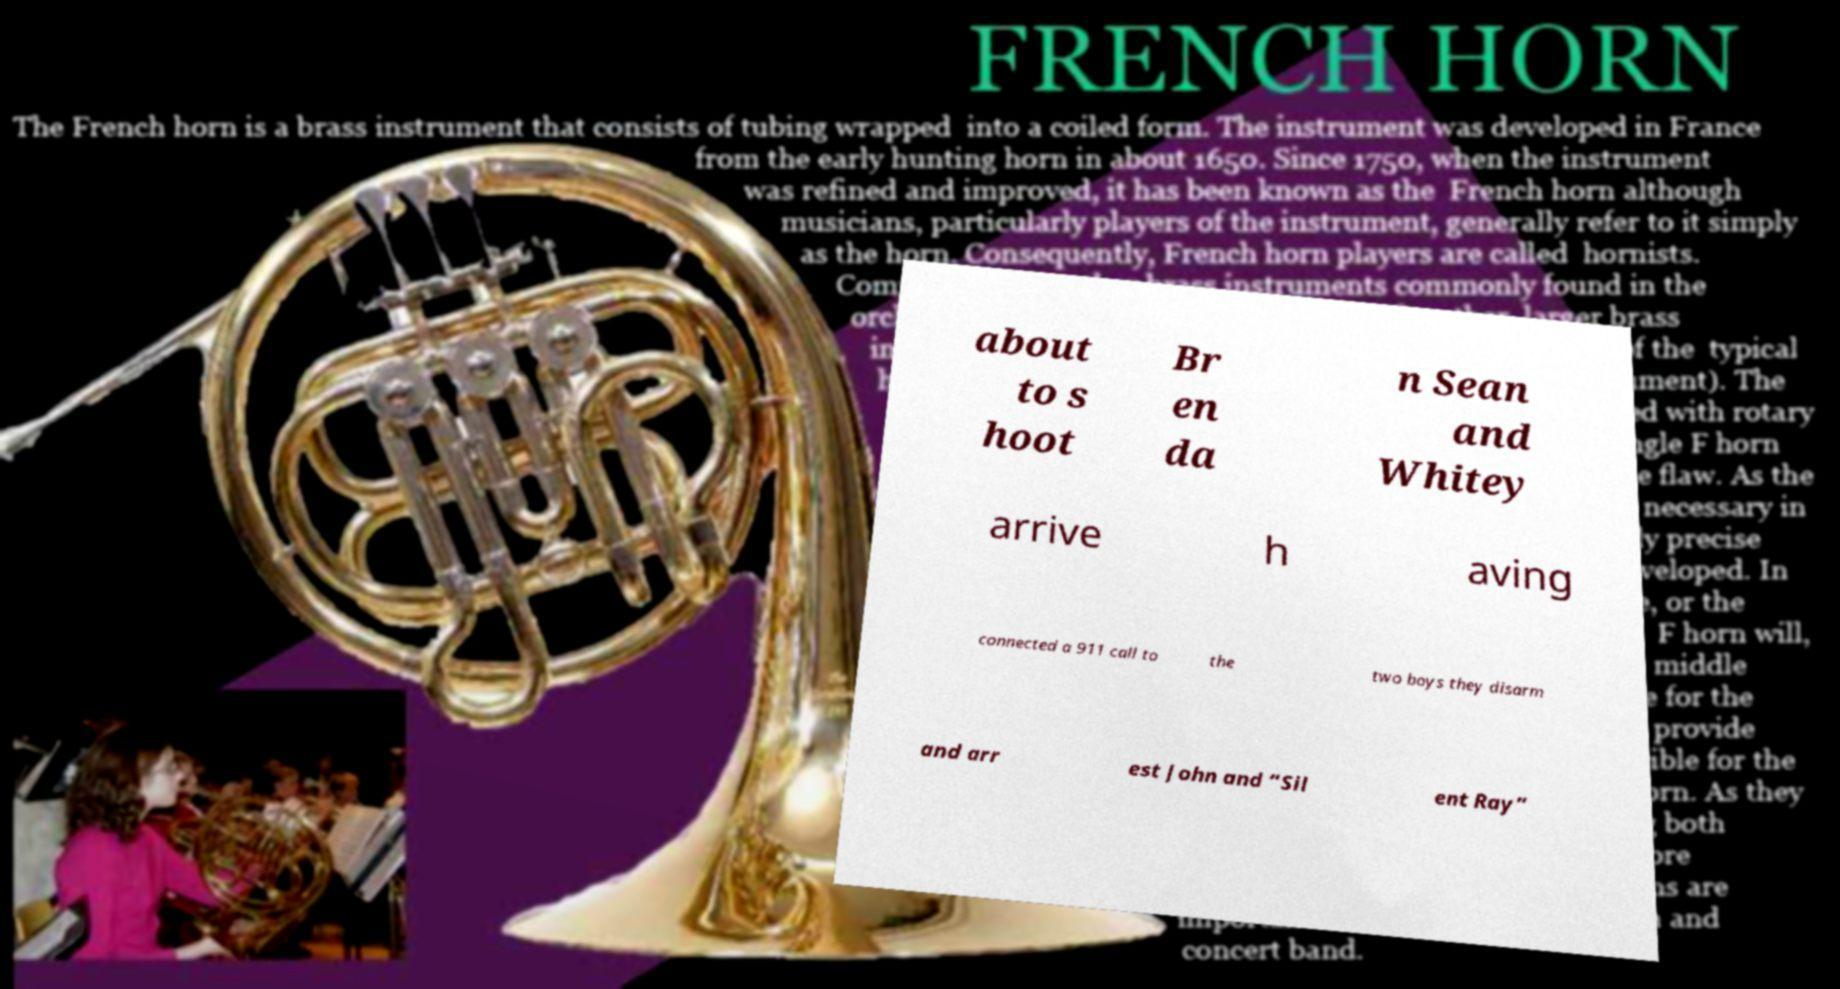I need the written content from this picture converted into text. Can you do that? about to s hoot Br en da n Sean and Whitey arrive h aving connected a 911 call to the two boys they disarm and arr est John and “Sil ent Ray” 